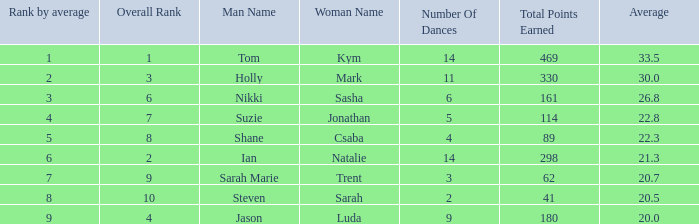What is the number of dances total number if the average is 22.3? 1.0. 